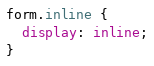<code> <loc_0><loc_0><loc_500><loc_500><_CSS_>
form.inline {
  display: inline;
}
</code> 